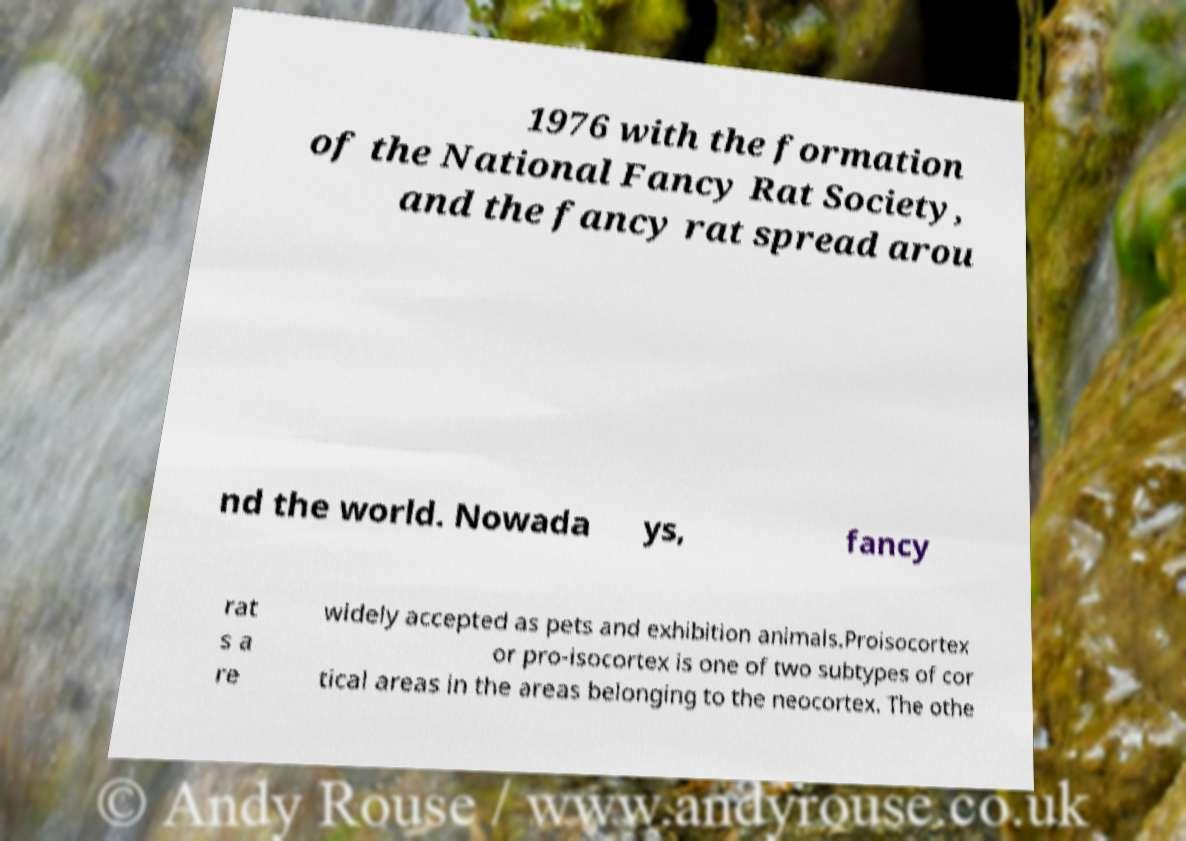I need the written content from this picture converted into text. Can you do that? 1976 with the formation of the National Fancy Rat Society, and the fancy rat spread arou nd the world. Nowada ys, fancy rat s a re widely accepted as pets and exhibition animals.Proisocortex or pro-isocortex is one of two subtypes of cor tical areas in the areas belonging to the neocortex. The othe 